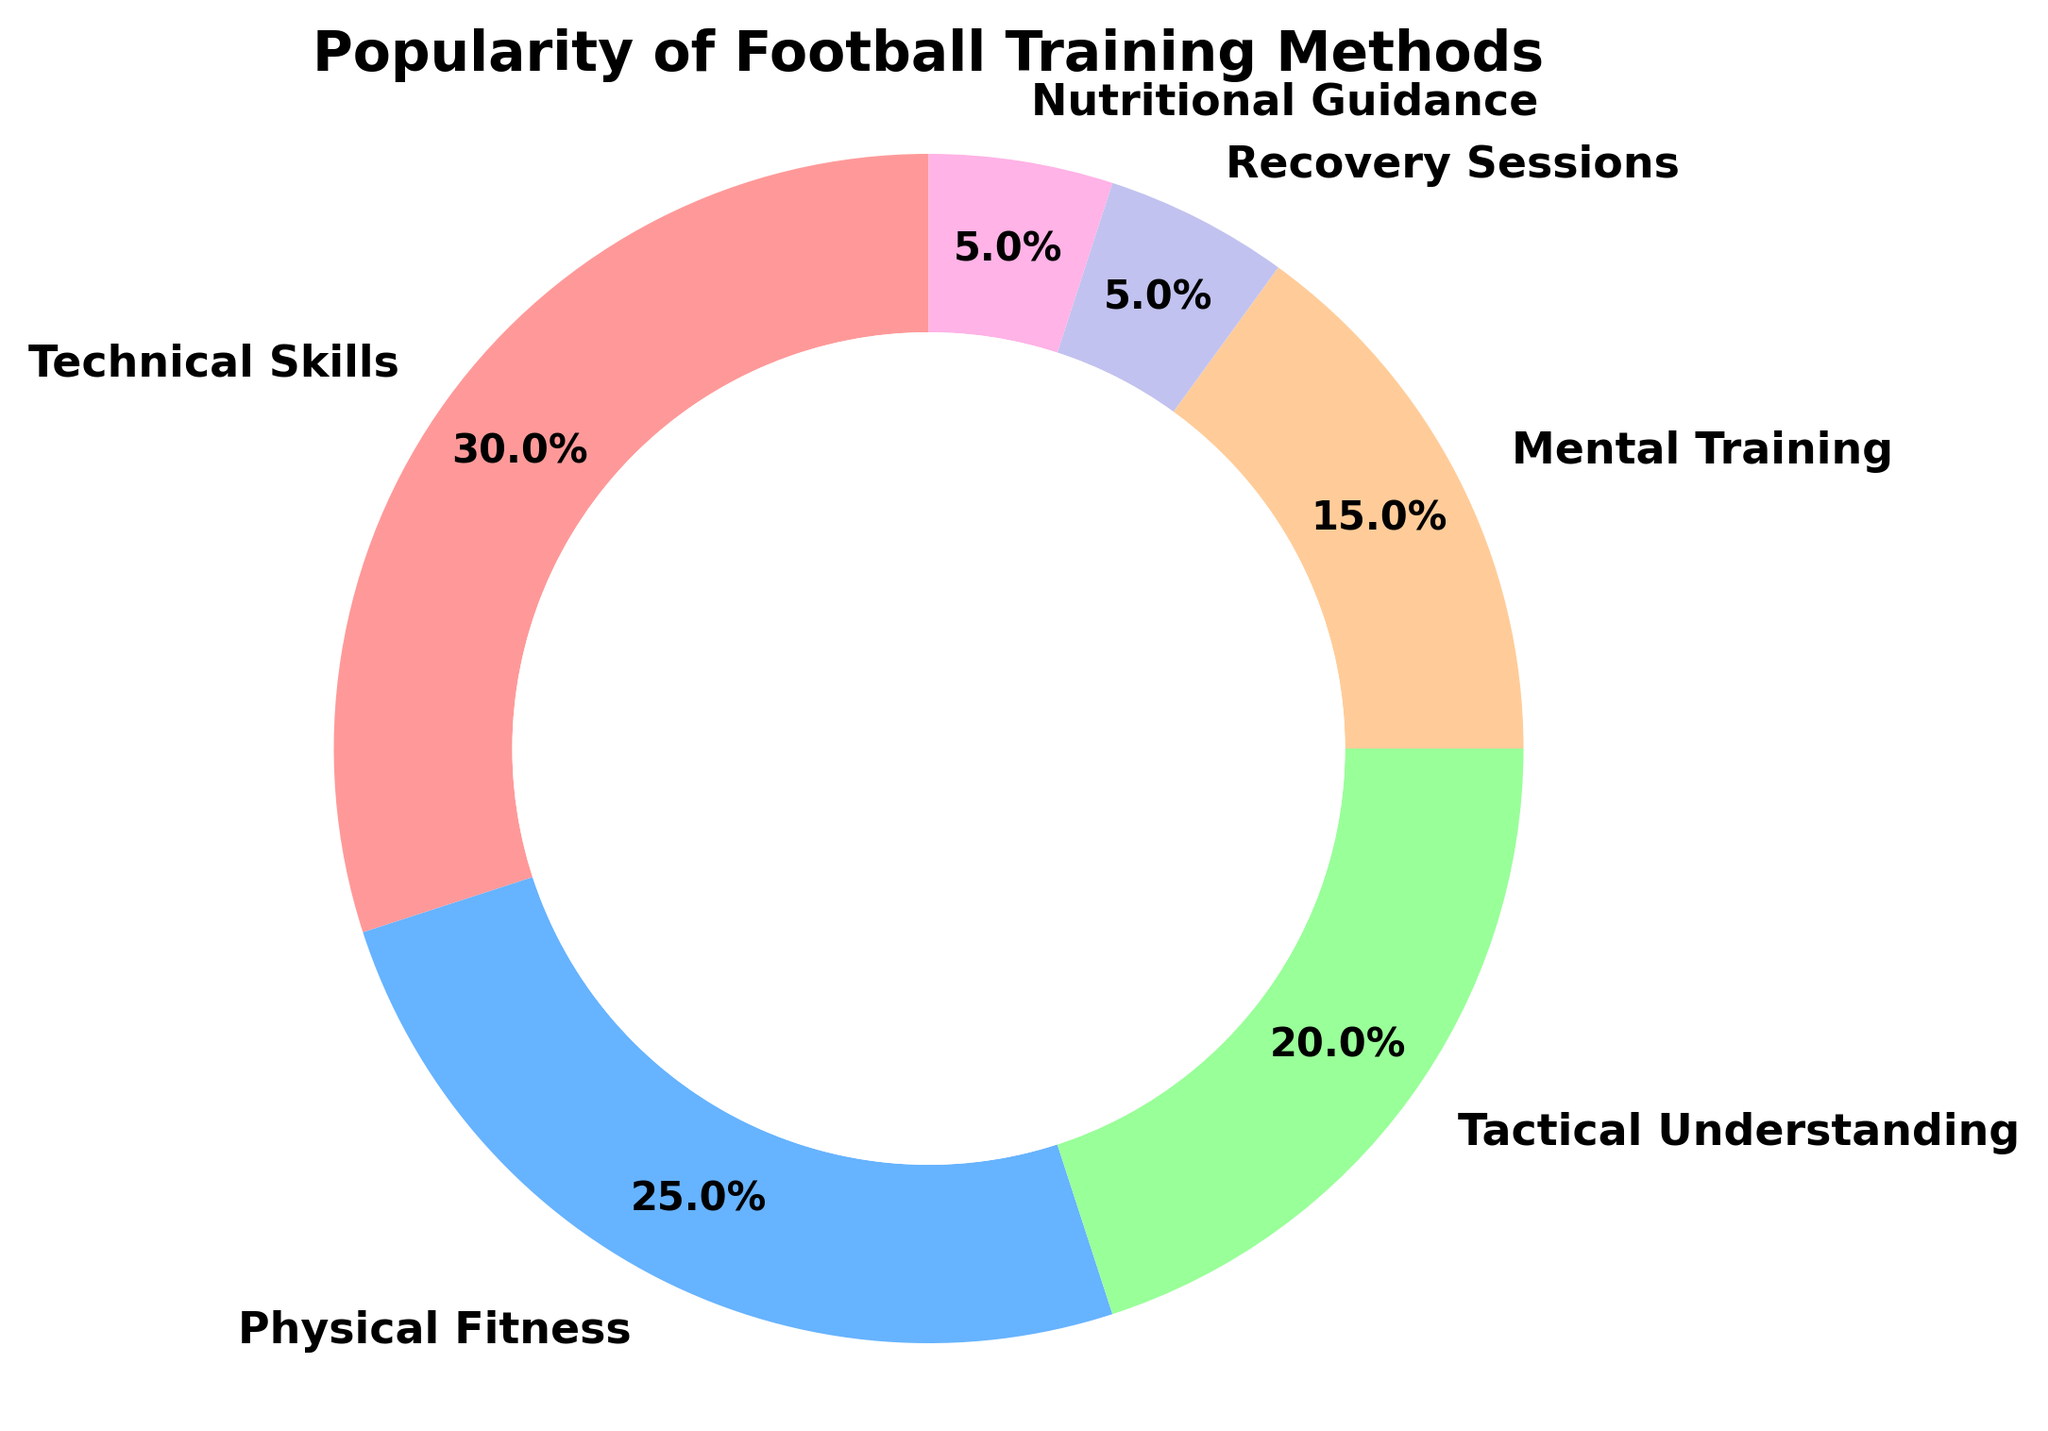What is the most popular football training method? According to the figure, the training method with the largest slice in the pie chart represents the most popular method. Technical Skills has the largest slice at 30%.
Answer: Technical Skills Which two training methods are equally popular? The pie chart has two slices of the same size. Recovery Sessions and Nutritional Guidance both have a slice labeled 5%.
Answer: Recovery Sessions and Nutritional Guidance How much more popular is Technical Skills compared to Tactical Understanding? Technical Skills is 30% and Tactical Understanding is 20%. The difference is 30% - 20% = 10%.
Answer: 10% What is the second least popular training method? By examining the pie chart, the second smallest slice, after Recovery Sessions and Nutritional Guidance (both at 5%), is Mental Training at 15%.
Answer: Mental Training Calculate the total percentage of training methods focused on physical aspects (Physical Fitness and Recovery Sessions). Physical Fitness is 25% and Recovery Sessions is 5%. Adding these together gives 25% + 5% = 30%.
Answer: 30% Which category has a larger percentage, Mental Training or Tactical Understanding, and by how much? Tactical Understanding is 20% and Mental Training is 15%. The difference is 20% - 15% = 5%.
Answer: Tactical Understanding by 5% List all the training methods that comprise less than 20% of the total. From the pie chart, the training methods with slices labeled less than 20% are Mental Training (15%), Recovery Sessions (5%), and Nutritional Guidance (5%).
Answer: Mental Training, Recovery Sessions, Nutritional Guidance What is the combined percentage of the top three most popular training methods? The top three most popular methods are Technical Skills (30%), Physical Fitness (25%), and Tactical Understanding (20%). Adding these gives 30% + 25% + 20% = 75%.
Answer: 75% 